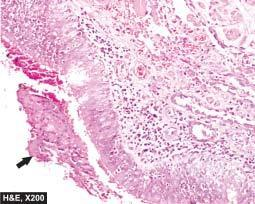s a scar smaller than the original wound thickened and infiltrated by acute and chronic inflammatory cells?
Answer the question using a single word or phrase. No 